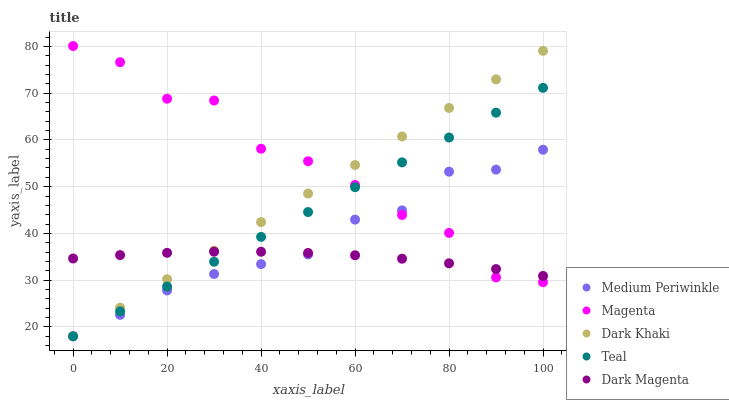Does Dark Magenta have the minimum area under the curve?
Answer yes or no. Yes. Does Magenta have the maximum area under the curve?
Answer yes or no. Yes. Does Medium Periwinkle have the minimum area under the curve?
Answer yes or no. No. Does Medium Periwinkle have the maximum area under the curve?
Answer yes or no. No. Is Teal the smoothest?
Answer yes or no. Yes. Is Magenta the roughest?
Answer yes or no. Yes. Is Medium Periwinkle the smoothest?
Answer yes or no. No. Is Medium Periwinkle the roughest?
Answer yes or no. No. Does Dark Khaki have the lowest value?
Answer yes or no. Yes. Does Magenta have the lowest value?
Answer yes or no. No. Does Magenta have the highest value?
Answer yes or no. Yes. Does Medium Periwinkle have the highest value?
Answer yes or no. No. Does Dark Khaki intersect Magenta?
Answer yes or no. Yes. Is Dark Khaki less than Magenta?
Answer yes or no. No. Is Dark Khaki greater than Magenta?
Answer yes or no. No. 